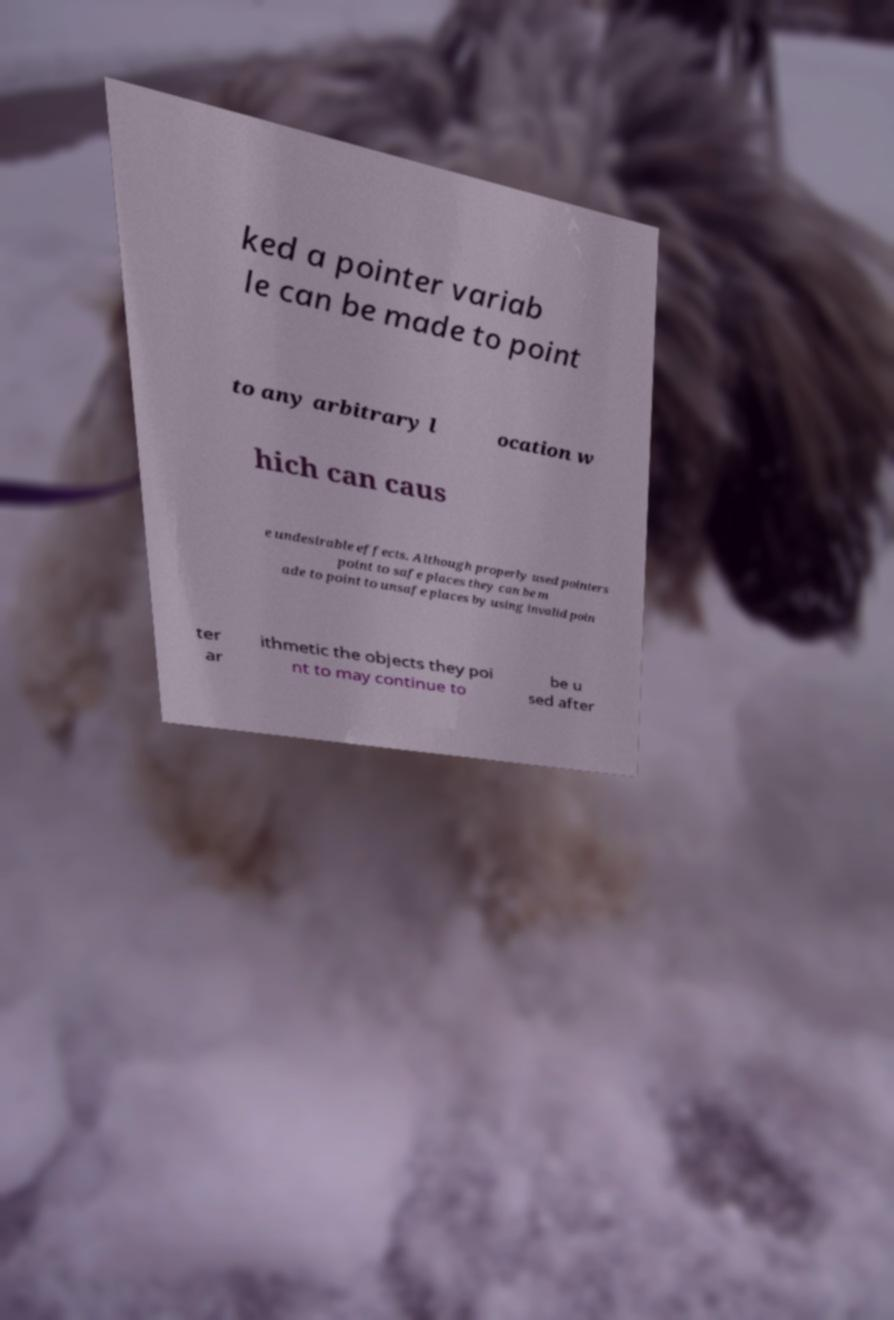Can you read and provide the text displayed in the image?This photo seems to have some interesting text. Can you extract and type it out for me? ked a pointer variab le can be made to point to any arbitrary l ocation w hich can caus e undesirable effects. Although properly used pointers point to safe places they can be m ade to point to unsafe places by using invalid poin ter ar ithmetic the objects they poi nt to may continue to be u sed after 